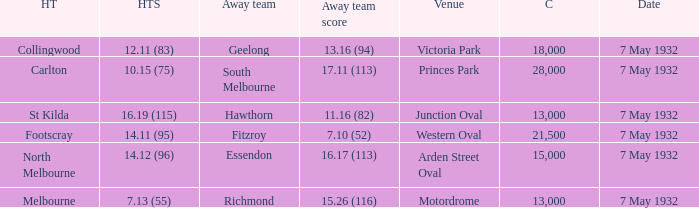What is the largest audience with away team score of 1 18000.0. 